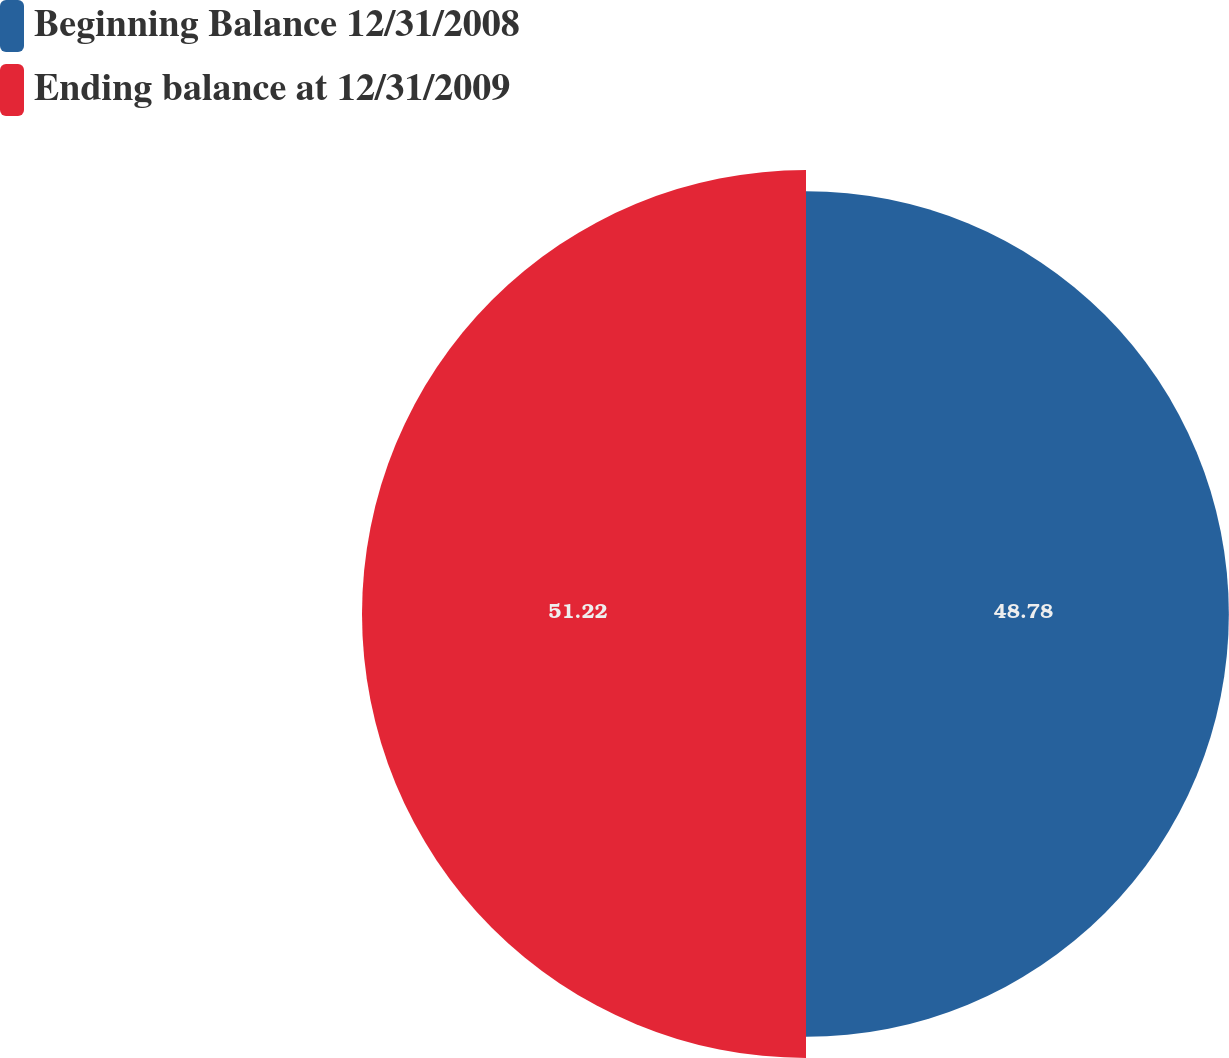Convert chart. <chart><loc_0><loc_0><loc_500><loc_500><pie_chart><fcel>Beginning Balance 12/31/2008<fcel>Ending balance at 12/31/2009<nl><fcel>48.78%<fcel>51.22%<nl></chart> 